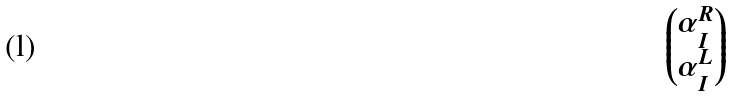Convert formula to latex. <formula><loc_0><loc_0><loc_500><loc_500>\begin{pmatrix} \alpha _ { I } ^ { R } \\ \alpha _ { I } ^ { L } \\ \end{pmatrix}</formula> 